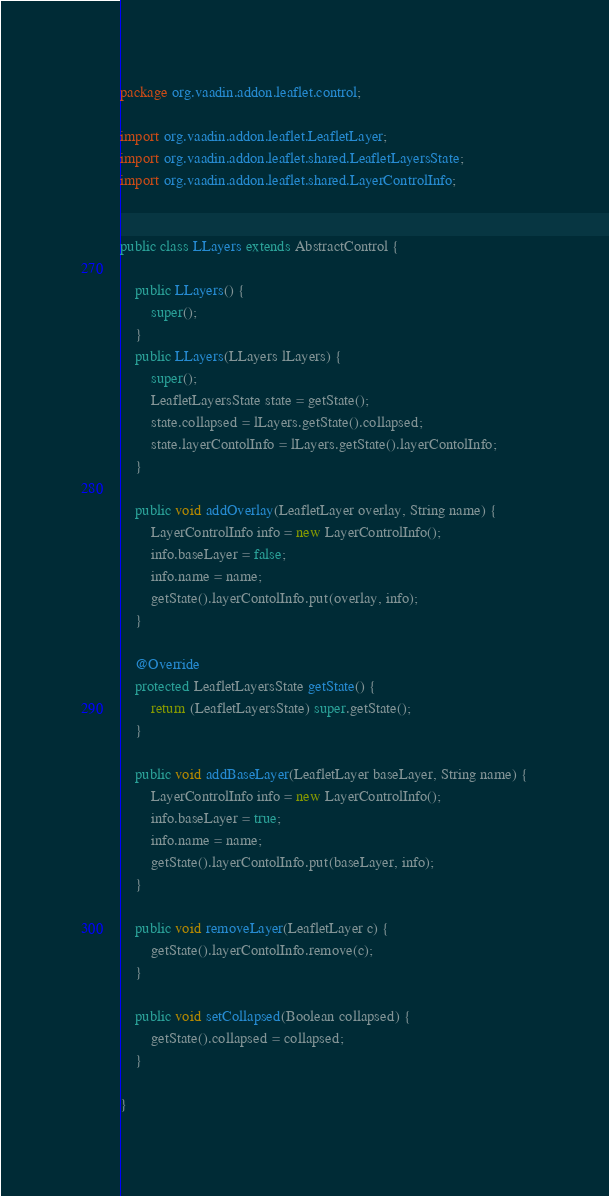<code> <loc_0><loc_0><loc_500><loc_500><_Java_>package org.vaadin.addon.leaflet.control;

import org.vaadin.addon.leaflet.LeafletLayer;
import org.vaadin.addon.leaflet.shared.LeafletLayersState;
import org.vaadin.addon.leaflet.shared.LayerControlInfo;


public class LLayers extends AbstractControl {

	public LLayers() {
		super();
	}
	public LLayers(LLayers lLayers) {
		super();
		LeafletLayersState state = getState();
		state.collapsed = lLayers.getState().collapsed;
		state.layerContolInfo = lLayers.getState().layerContolInfo;
	}

	public void addOverlay(LeafletLayer overlay, String name) {
		LayerControlInfo info = new LayerControlInfo();
		info.baseLayer = false;
		info.name = name;
		getState().layerContolInfo.put(overlay, info);
	}
	
	@Override
	protected LeafletLayersState getState() {
		return (LeafletLayersState) super.getState();
	}

	public void addBaseLayer(LeafletLayer baseLayer, String name) {
		LayerControlInfo info = new LayerControlInfo();
		info.baseLayer = true;
		info.name = name;
		getState().layerContolInfo.put(baseLayer, info);
	}

	public void removeLayer(LeafletLayer c) {
		getState().layerContolInfo.remove(c);
	}

    public void setCollapsed(Boolean collapsed) {
        getState().collapsed = collapsed;
    }

}
</code> 